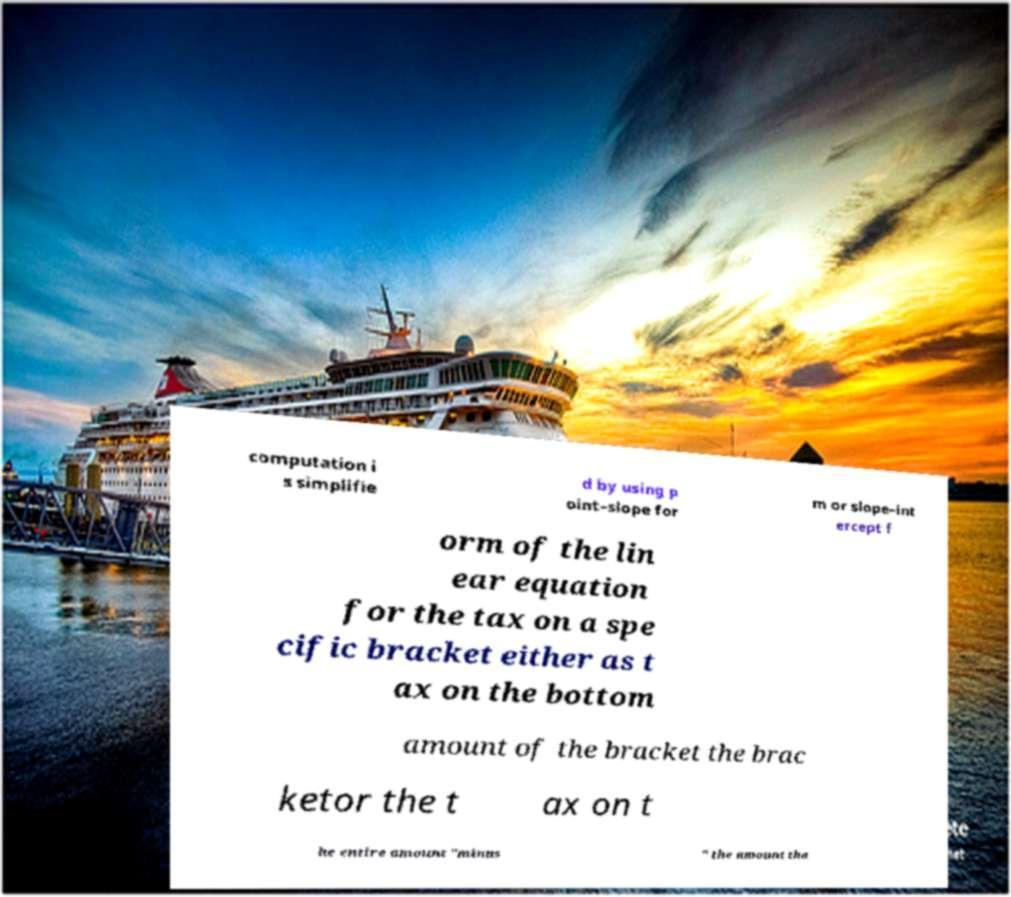Please identify and transcribe the text found in this image. computation i s simplifie d by using p oint–slope for m or slope–int ercept f orm of the lin ear equation for the tax on a spe cific bracket either as t ax on the bottom amount of the bracket the brac ketor the t ax on t he entire amount "minus " the amount tha 